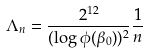Convert formula to latex. <formula><loc_0><loc_0><loc_500><loc_500>\Lambda _ { n } = \frac { 2 ^ { 1 2 } } { ( \log { \phi ( \beta _ { 0 } ) } ) ^ { 2 } } \frac { 1 } { n }</formula> 